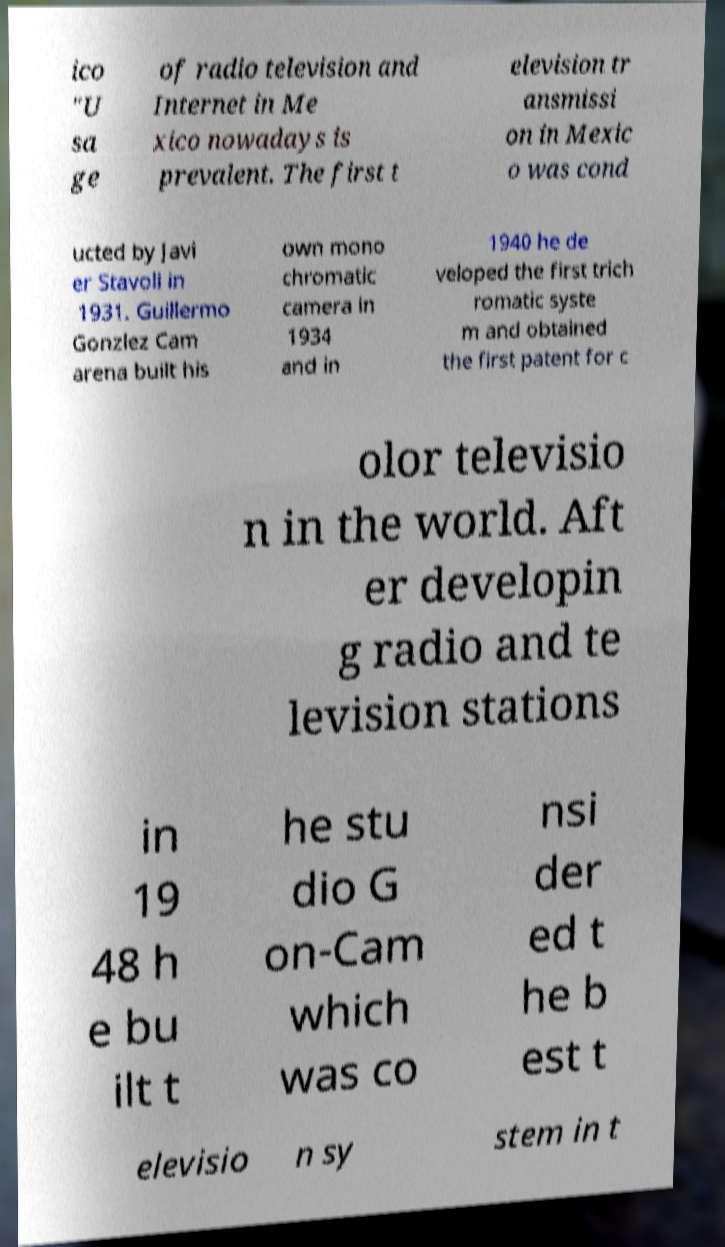Can you read and provide the text displayed in the image?This photo seems to have some interesting text. Can you extract and type it out for me? ico "U sa ge of radio television and Internet in Me xico nowadays is prevalent. The first t elevision tr ansmissi on in Mexic o was cond ucted by Javi er Stavoli in 1931. Guillermo Gonzlez Cam arena built his own mono chromatic camera in 1934 and in 1940 he de veloped the first trich romatic syste m and obtained the first patent for c olor televisio n in the world. Aft er developin g radio and te levision stations in 19 48 h e bu ilt t he stu dio G on-Cam which was co nsi der ed t he b est t elevisio n sy stem in t 